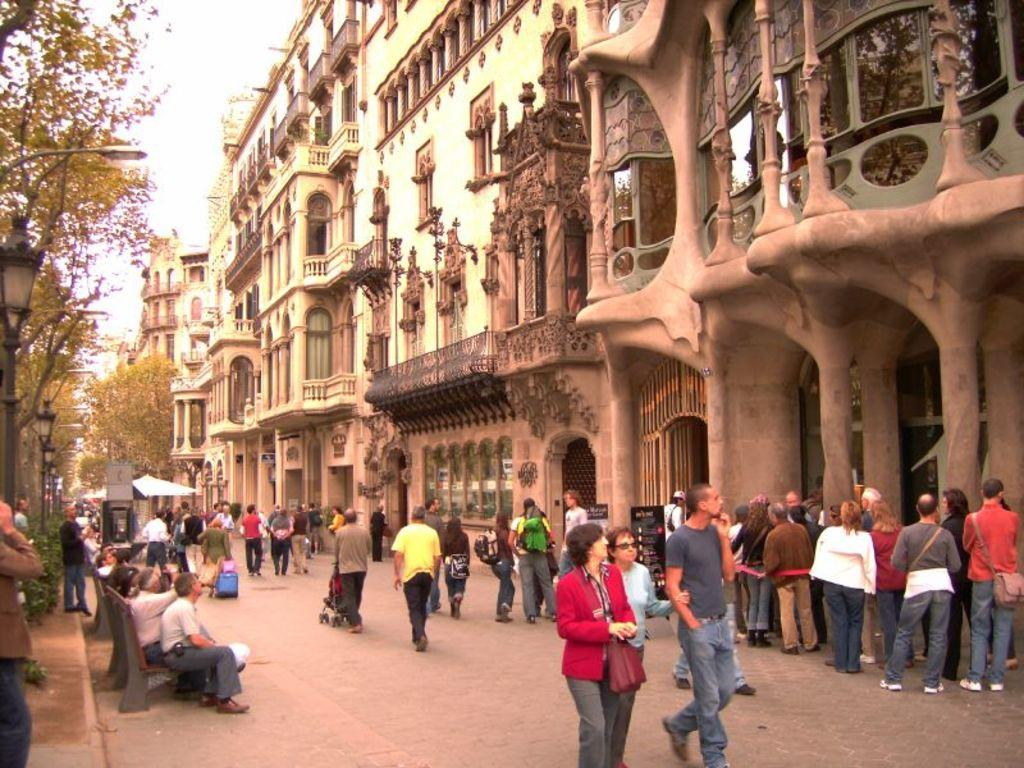How many people are in the image? There is a group of people in the image, but the exact number cannot be determined from the provided facts. What can be seen on the ground in the image? There are objects on the ground in the image, but their specific nature is not mentioned in the facts. What is visible in the background of the image? In the background of the image, there are buildings, trees, electric poles with lights, and the sky. Can you describe the setting of the image? The image appears to be set in an urban environment, with buildings, electric poles, and trees visible in the background. How many cherries are being held by the goldfish in the image? There are no cherries or goldfish present in the image. 